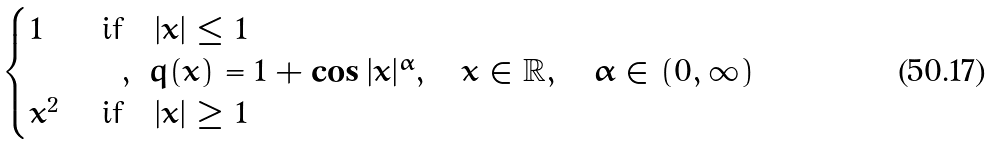Convert formula to latex. <formula><loc_0><loc_0><loc_500><loc_500>\begin{cases} 1 & \ \text {if} \quad | x | \leq 1 \\ & \quad , \ q ( x ) = 1 + \cos | x | ^ { \alpha } , \quad x \in \mathbb { R } , \quad \alpha \in ( 0 , \infty ) \\ x ^ { 2 } & \ \text {if} \quad | x | \geq 1 \end{cases}</formula> 